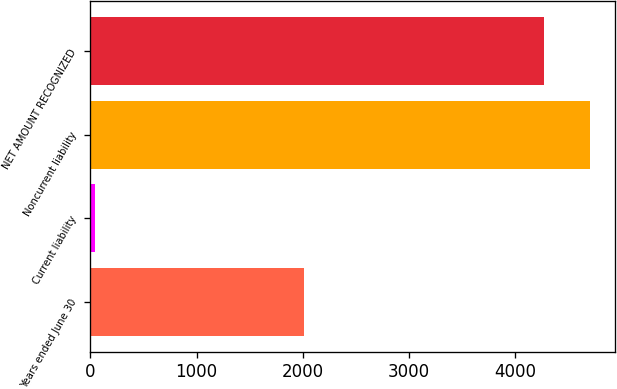Convert chart. <chart><loc_0><loc_0><loc_500><loc_500><bar_chart><fcel>Years ended June 30<fcel>Current liability<fcel>Noncurrent liability<fcel>NET AMOUNT RECOGNIZED<nl><fcel>2011<fcel>47<fcel>4701.1<fcel>4267<nl></chart> 